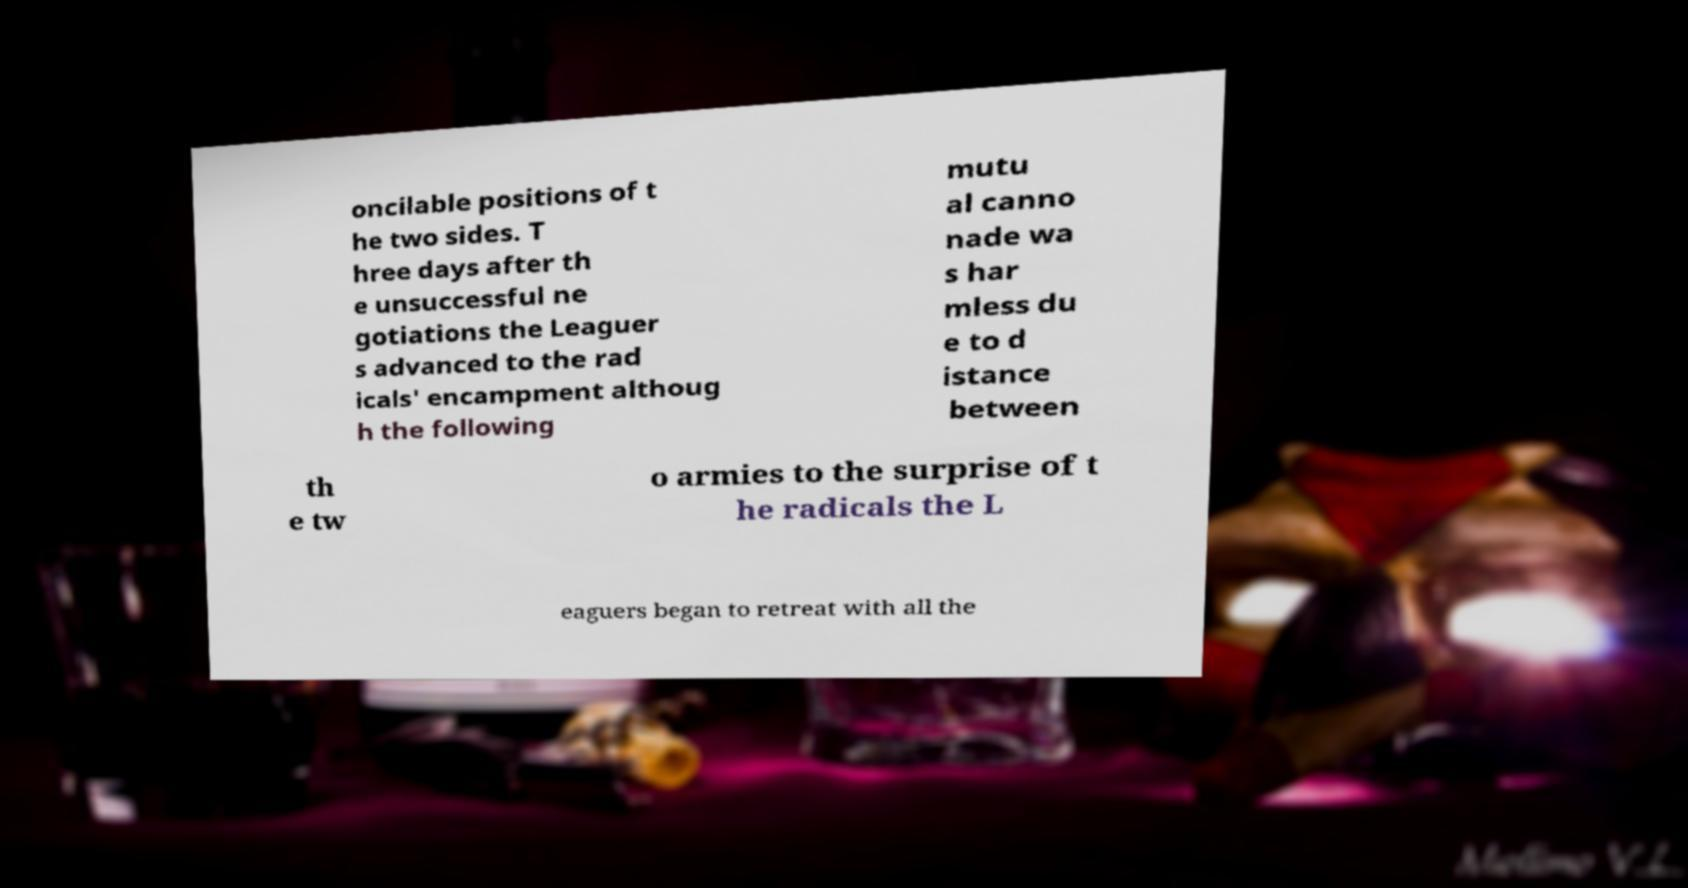Could you extract and type out the text from this image? oncilable positions of t he two sides. T hree days after th e unsuccessful ne gotiations the Leaguer s advanced to the rad icals' encampment althoug h the following mutu al canno nade wa s har mless du e to d istance between th e tw o armies to the surprise of t he radicals the L eaguers began to retreat with all the 